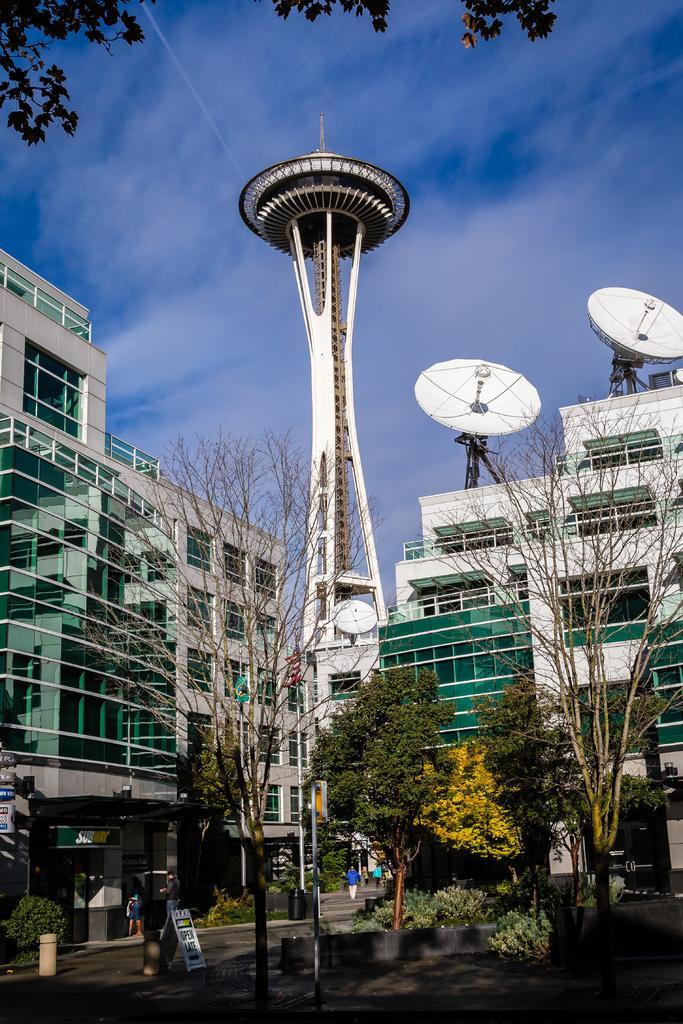Could you give a brief overview of what you see in this image? In this picture we can see trees, buildings, board, bin, antennas, name boards, two people on the ground and in the background we can see the sky with clouds. 